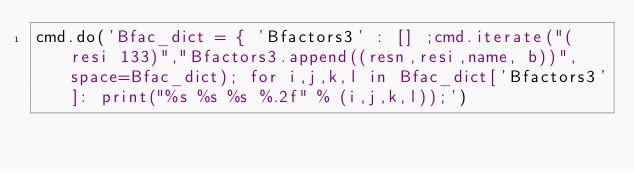Convert code to text. <code><loc_0><loc_0><loc_500><loc_500><_Python_>cmd.do('Bfac_dict = { 'Bfactors3' : [] ;cmd.iterate("(resi 133)","Bfactors3.append((resn,resi,name, b))", space=Bfac_dict); for i,j,k,l in Bfac_dict['Bfactors3']: print("%s %s %s %.2f" % (i,j,k,l));')
</code> 